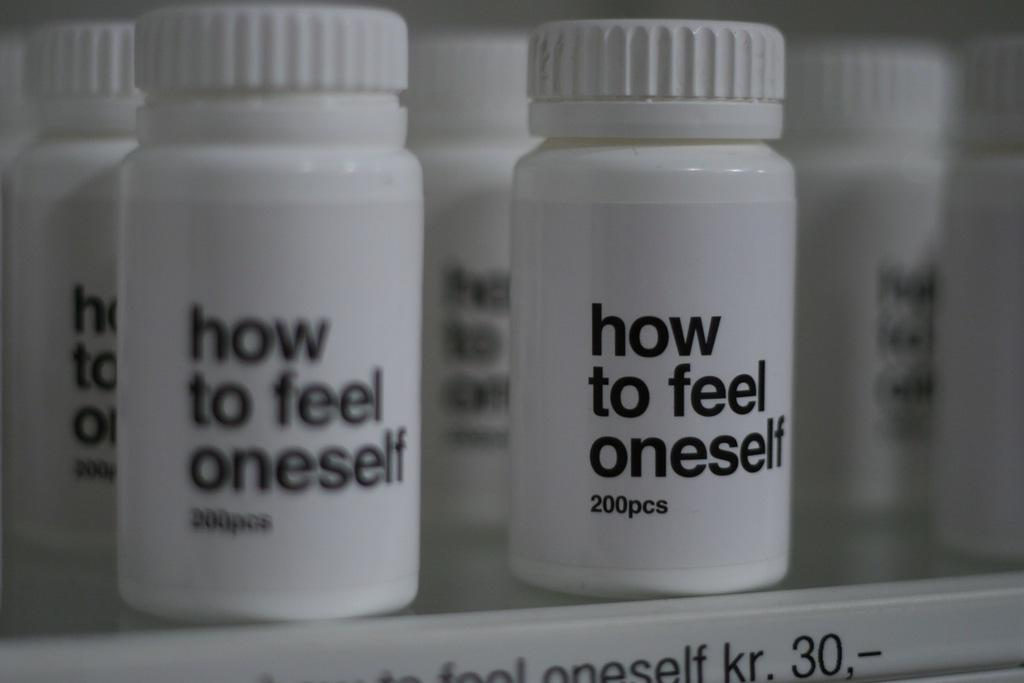<image>
Relay a brief, clear account of the picture shown. A shelf with bottles of how to fell oneself lined up. 